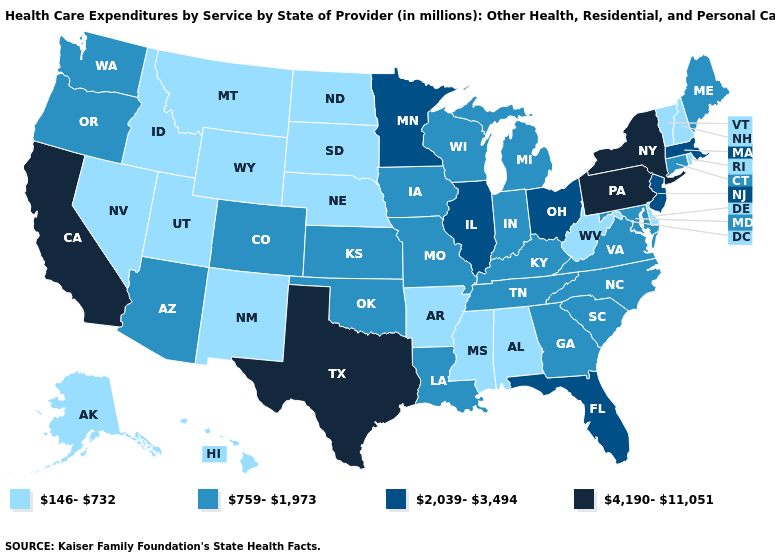Name the states that have a value in the range 759-1,973?
Short answer required. Arizona, Colorado, Connecticut, Georgia, Indiana, Iowa, Kansas, Kentucky, Louisiana, Maine, Maryland, Michigan, Missouri, North Carolina, Oklahoma, Oregon, South Carolina, Tennessee, Virginia, Washington, Wisconsin. Does Washington have the same value as Iowa?
Concise answer only. Yes. What is the value of California?
Concise answer only. 4,190-11,051. What is the lowest value in the USA?
Be succinct. 146-732. Which states have the lowest value in the USA?
Quick response, please. Alabama, Alaska, Arkansas, Delaware, Hawaii, Idaho, Mississippi, Montana, Nebraska, Nevada, New Hampshire, New Mexico, North Dakota, Rhode Island, South Dakota, Utah, Vermont, West Virginia, Wyoming. What is the lowest value in the Northeast?
Quick response, please. 146-732. Among the states that border Colorado , which have the highest value?
Quick response, please. Arizona, Kansas, Oklahoma. Name the states that have a value in the range 146-732?
Quick response, please. Alabama, Alaska, Arkansas, Delaware, Hawaii, Idaho, Mississippi, Montana, Nebraska, Nevada, New Hampshire, New Mexico, North Dakota, Rhode Island, South Dakota, Utah, Vermont, West Virginia, Wyoming. What is the value of Minnesota?
Be succinct. 2,039-3,494. Which states have the highest value in the USA?
Quick response, please. California, New York, Pennsylvania, Texas. Name the states that have a value in the range 2,039-3,494?
Give a very brief answer. Florida, Illinois, Massachusetts, Minnesota, New Jersey, Ohio. What is the highest value in states that border Connecticut?
Write a very short answer. 4,190-11,051. What is the lowest value in states that border Montana?
Keep it brief. 146-732. What is the value of Wyoming?
Concise answer only. 146-732. Does Alaska have the lowest value in the USA?
Short answer required. Yes. 